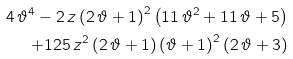<formula> <loc_0><loc_0><loc_500><loc_500>4 \, { \vartheta } ^ { 4 } - 2 \, z \left ( 2 \, \vartheta + 1 \right ) ^ { 2 } \left ( 1 1 \, { \vartheta } ^ { 2 } + 1 1 \, \vartheta + 5 \right ) \\ + 1 2 5 \, { z } ^ { 2 } \left ( 2 \, \vartheta + 1 \right ) \left ( \vartheta + 1 \right ) ^ { 2 } \left ( 2 \, \vartheta + 3 \right )</formula> 